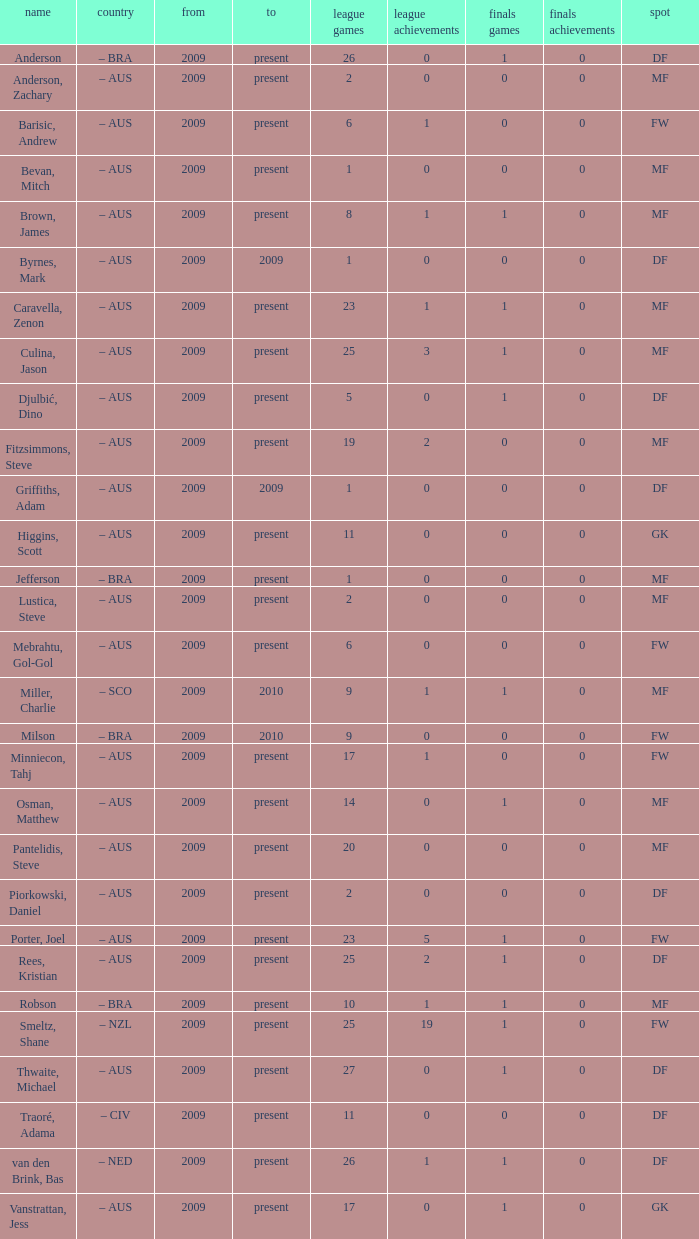Name the mosst finals apps 1.0. 